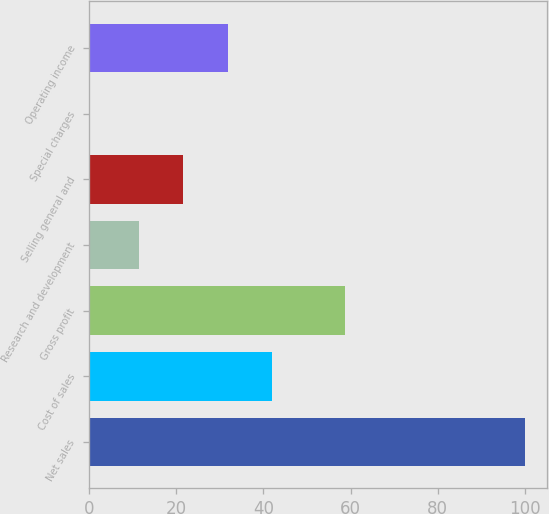<chart> <loc_0><loc_0><loc_500><loc_500><bar_chart><fcel>Net sales<fcel>Cost of sales<fcel>Gross profit<fcel>Research and development<fcel>Selling general and<fcel>Special charges<fcel>Operating income<nl><fcel>100<fcel>41.89<fcel>58.8<fcel>11.5<fcel>21.49<fcel>0.1<fcel>31.9<nl></chart> 